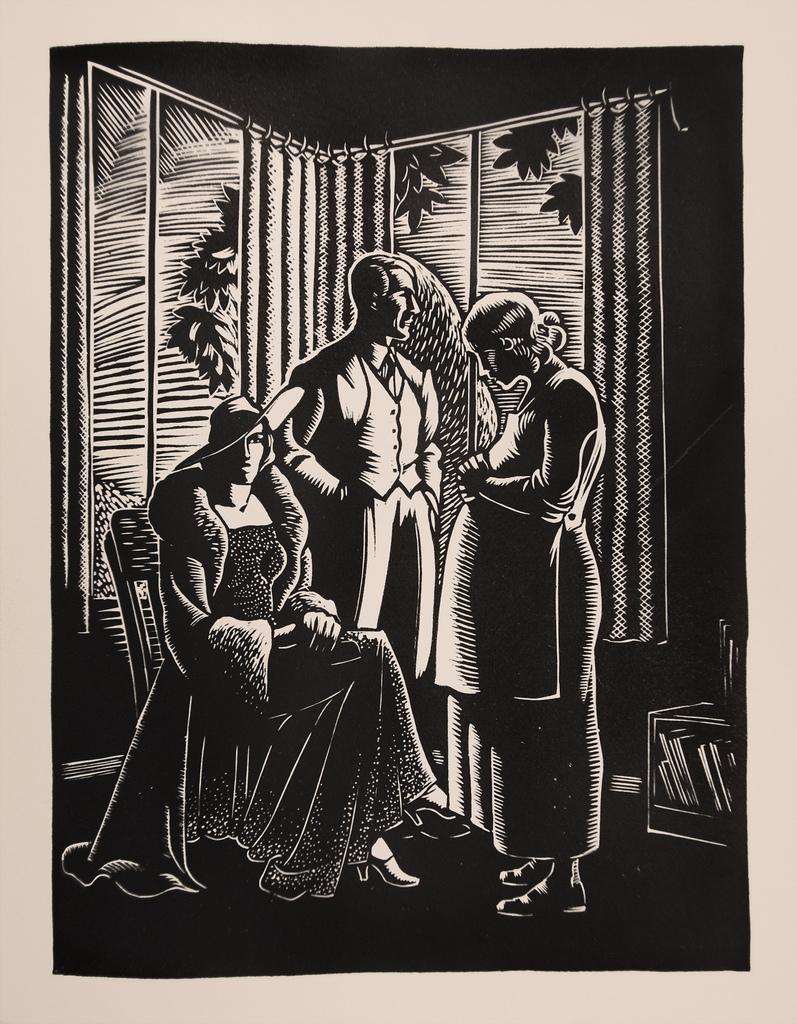In one or two sentences, can you explain what this image depicts? In this image we can see three persons. One person wearing hat is sitting on a chair. Two are standing. Also there is a stand with books. In the back there are curtains. 